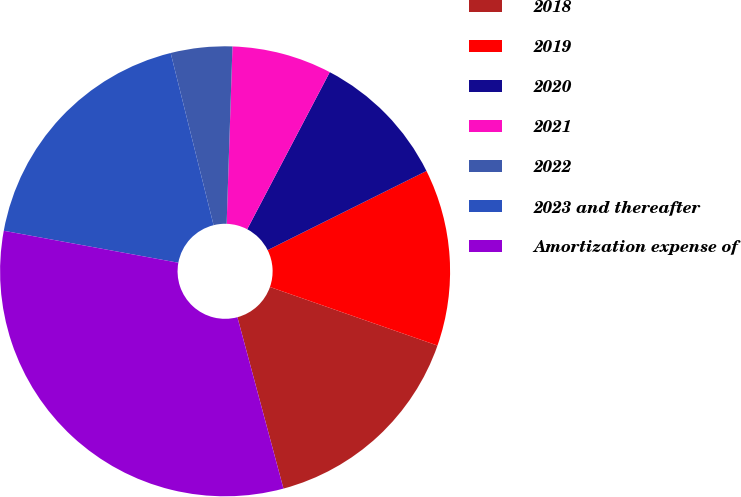<chart> <loc_0><loc_0><loc_500><loc_500><pie_chart><fcel>2018<fcel>2019<fcel>2020<fcel>2021<fcel>2022<fcel>2023 and thereafter<fcel>Amortization expense of<nl><fcel>15.47%<fcel>12.71%<fcel>9.94%<fcel>7.18%<fcel>4.41%<fcel>18.23%<fcel>32.06%<nl></chart> 